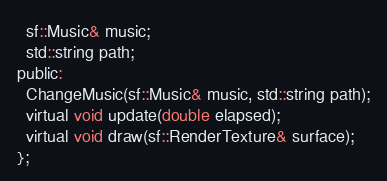<code> <loc_0><loc_0><loc_500><loc_500><_C_>  sf::Music& music;
  std::string path;
public:
  ChangeMusic(sf::Music& music, std::string path);
  virtual void update(double elapsed);
  virtual void draw(sf::RenderTexture& surface);
};</code> 